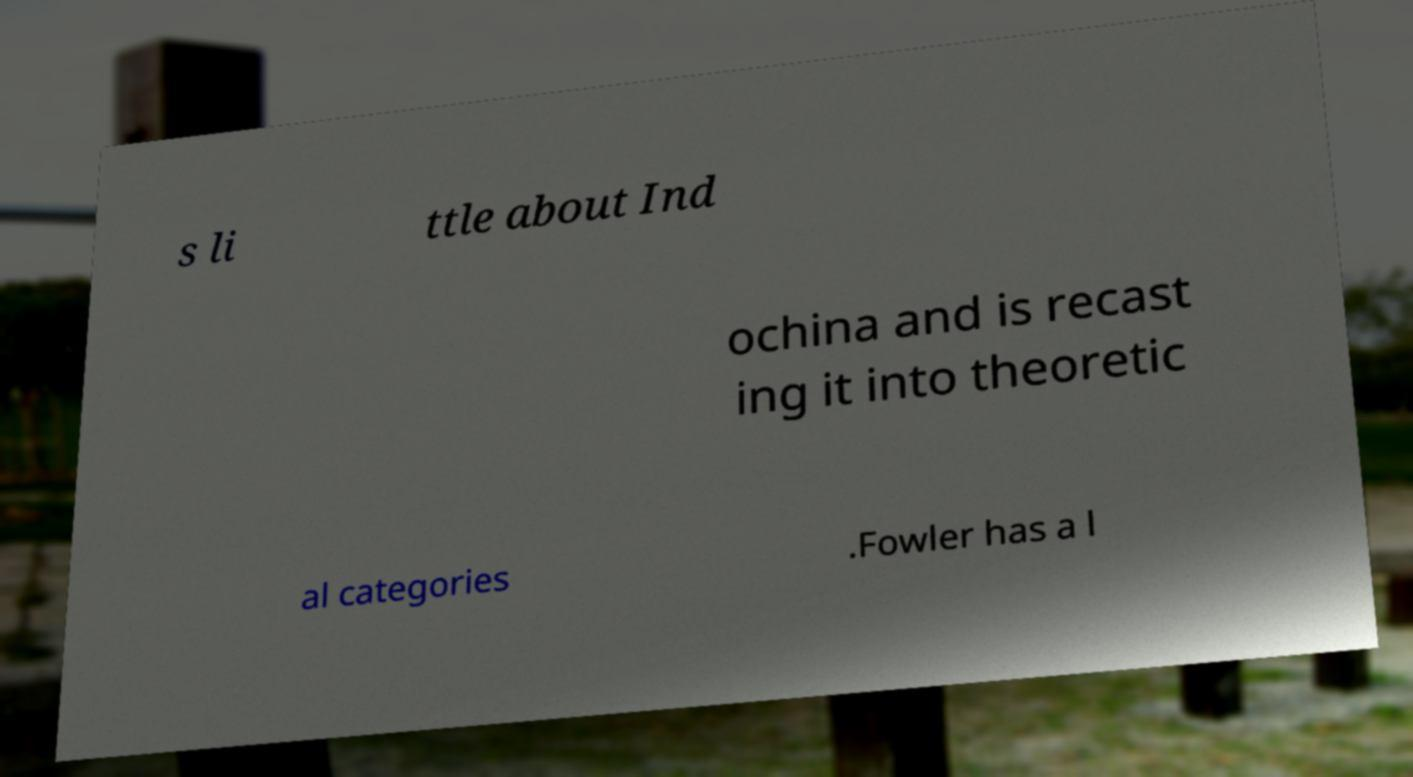I need the written content from this picture converted into text. Can you do that? s li ttle about Ind ochina and is recast ing it into theoretic al categories .Fowler has a l 